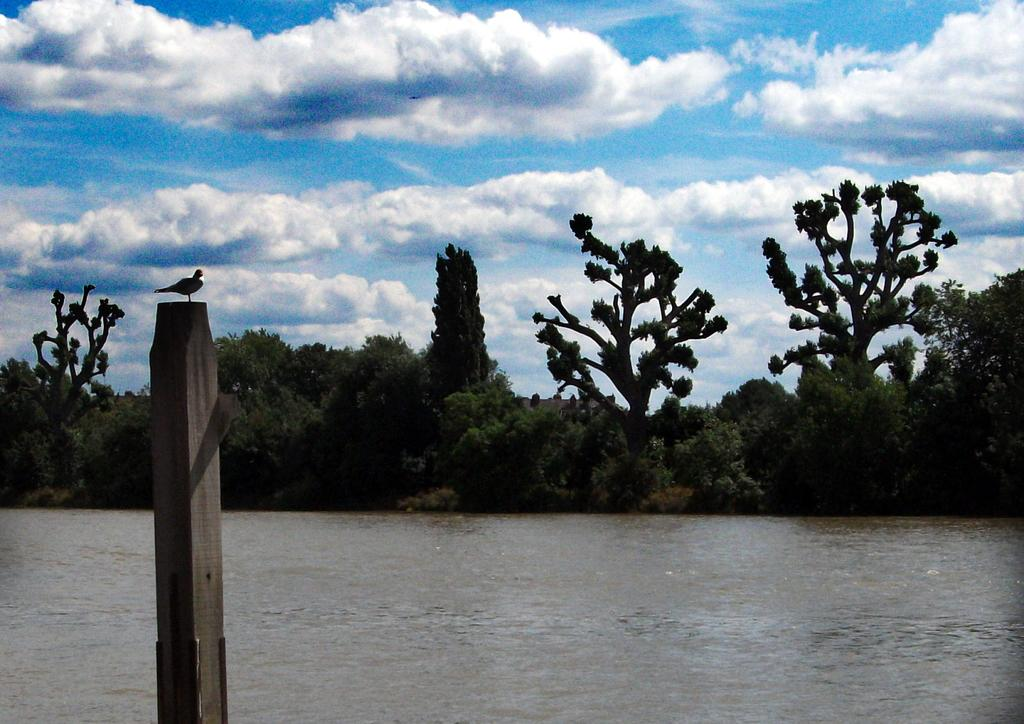What type of animal can be seen in the image? There is a bird in the image. Where is the bird located? The bird is on a wooden pole. What can be seen in the background of the image? There is water and trees visible in the background of the image. What is the color of the sky in the image? The sky is blue and white in color. What level of care does the bird require in the image? The image does not provide information about the bird's care requirements. What smell can be detected in the image? The image does not provide information about any smells. 